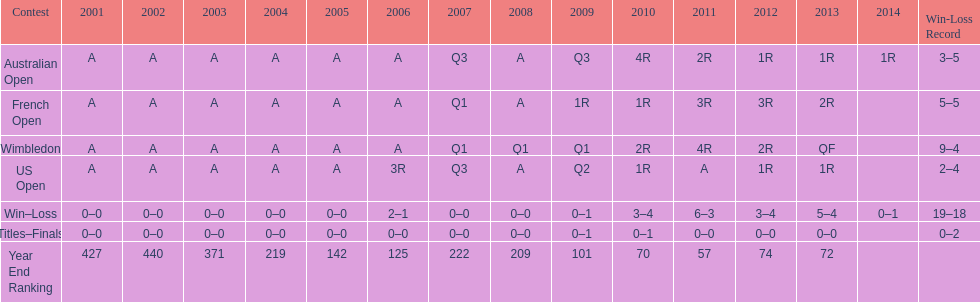What was this players average ranking between 2001 and 2006? 287. 